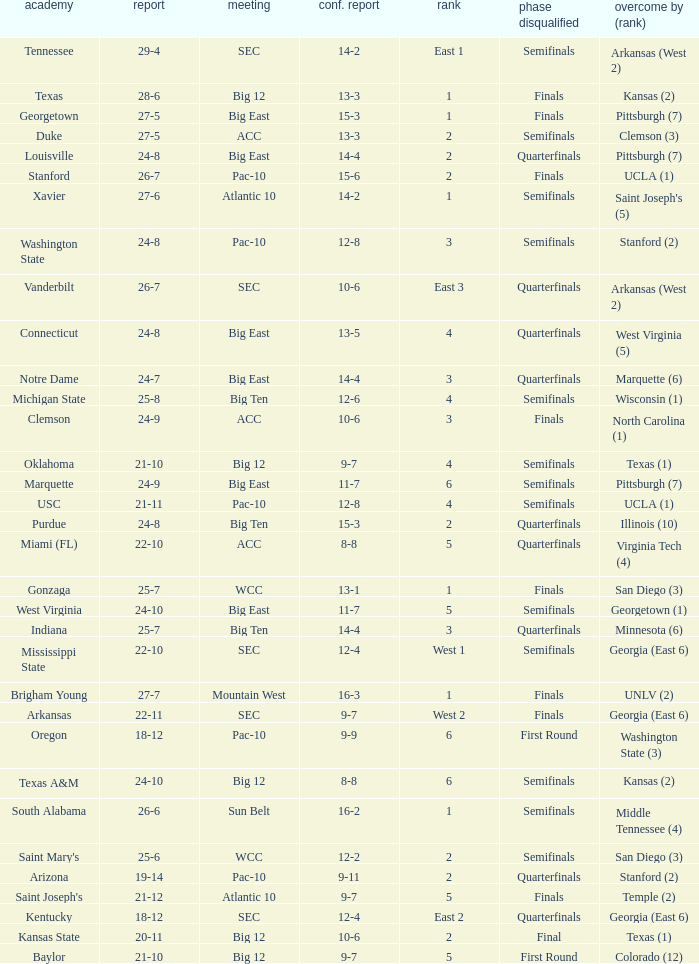Name the round eliminated where conference record is 12-6 Semifinals. 